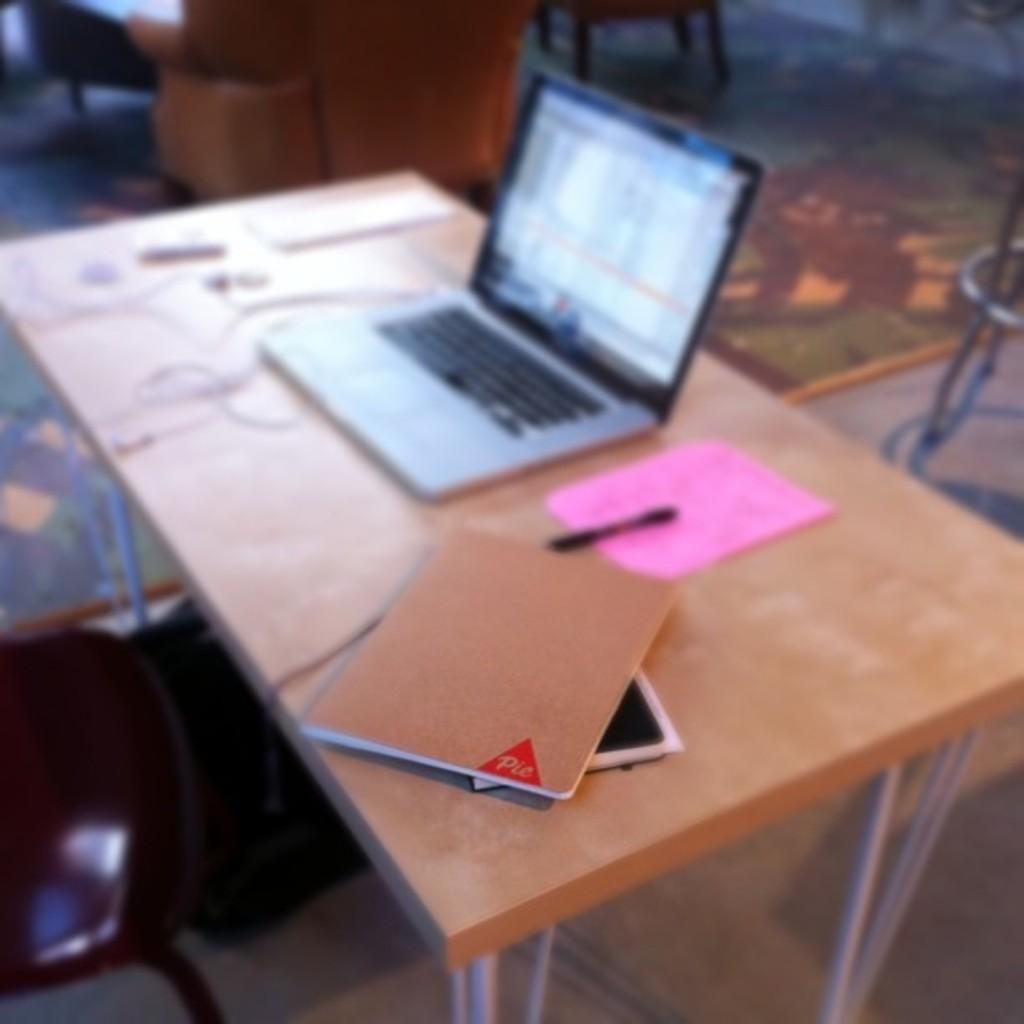What type of furniture is present in the image? There is a table in the image. What items can be seen on the table? There are books, a pen, and a laptop on the table. What type of seating is located near the table? There is a chair near the table. What type of alley can be seen in the image? There is no alley present in the image. What color is the gold in the image? There is no gold present in the image. 